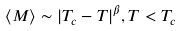<formula> <loc_0><loc_0><loc_500><loc_500>\langle M \rangle \sim | T _ { c } - T | ^ { \beta } , T < T _ { c }</formula> 